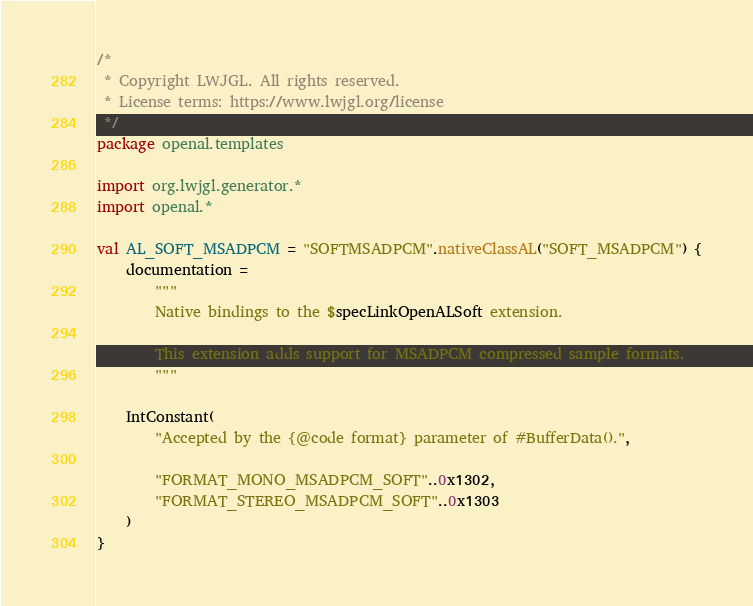<code> <loc_0><loc_0><loc_500><loc_500><_Kotlin_>/*
 * Copyright LWJGL. All rights reserved.
 * License terms: https://www.lwjgl.org/license
 */
package openal.templates

import org.lwjgl.generator.*
import openal.*

val AL_SOFT_MSADPCM = "SOFTMSADPCM".nativeClassAL("SOFT_MSADPCM") {
    documentation =
        """
        Native bindings to the $specLinkOpenALSoft extension.

        This extension adds support for MSADPCM compressed sample formats.
        """

    IntConstant(
        "Accepted by the {@code format} parameter of #BufferData().",

        "FORMAT_MONO_MSADPCM_SOFT"..0x1302,
        "FORMAT_STEREO_MSADPCM_SOFT"..0x1303
    )
}</code> 